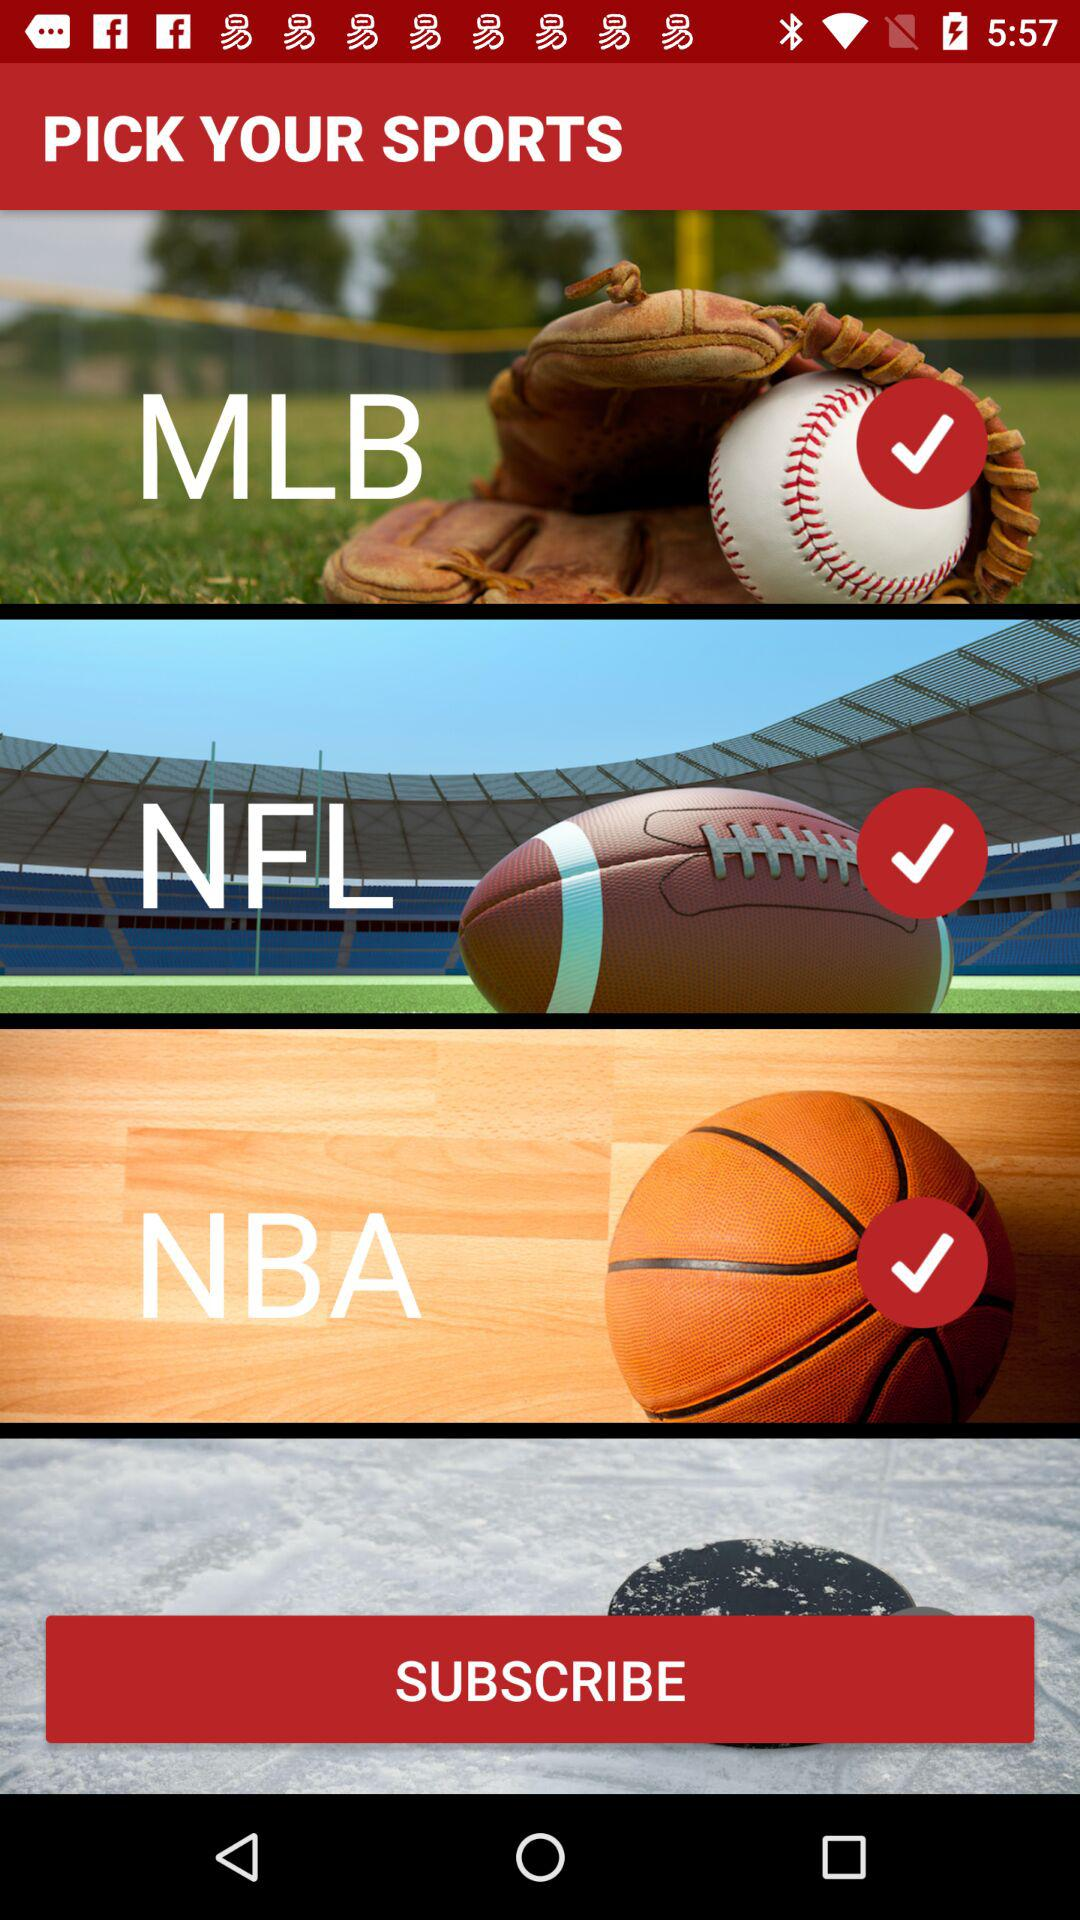What are the selected sports? The selected sports are "MLB", "NFL", and "NBA". 